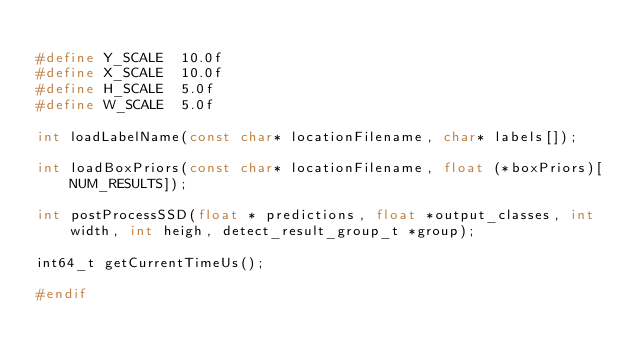<code> <loc_0><loc_0><loc_500><loc_500><_C_>
#define Y_SCALE  10.0f
#define X_SCALE  10.0f
#define H_SCALE  5.0f
#define W_SCALE  5.0f

int loadLabelName(const char* locationFilename, char* labels[]);

int loadBoxPriors(const char* locationFilename, float (*boxPriors)[NUM_RESULTS]);

int postProcessSSD(float * predictions, float *output_classes, int width, int heigh, detect_result_group_t *group);

int64_t getCurrentTimeUs();

#endif
</code> 